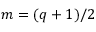Convert formula to latex. <formula><loc_0><loc_0><loc_500><loc_500>m = ( q + 1 ) / 2</formula> 